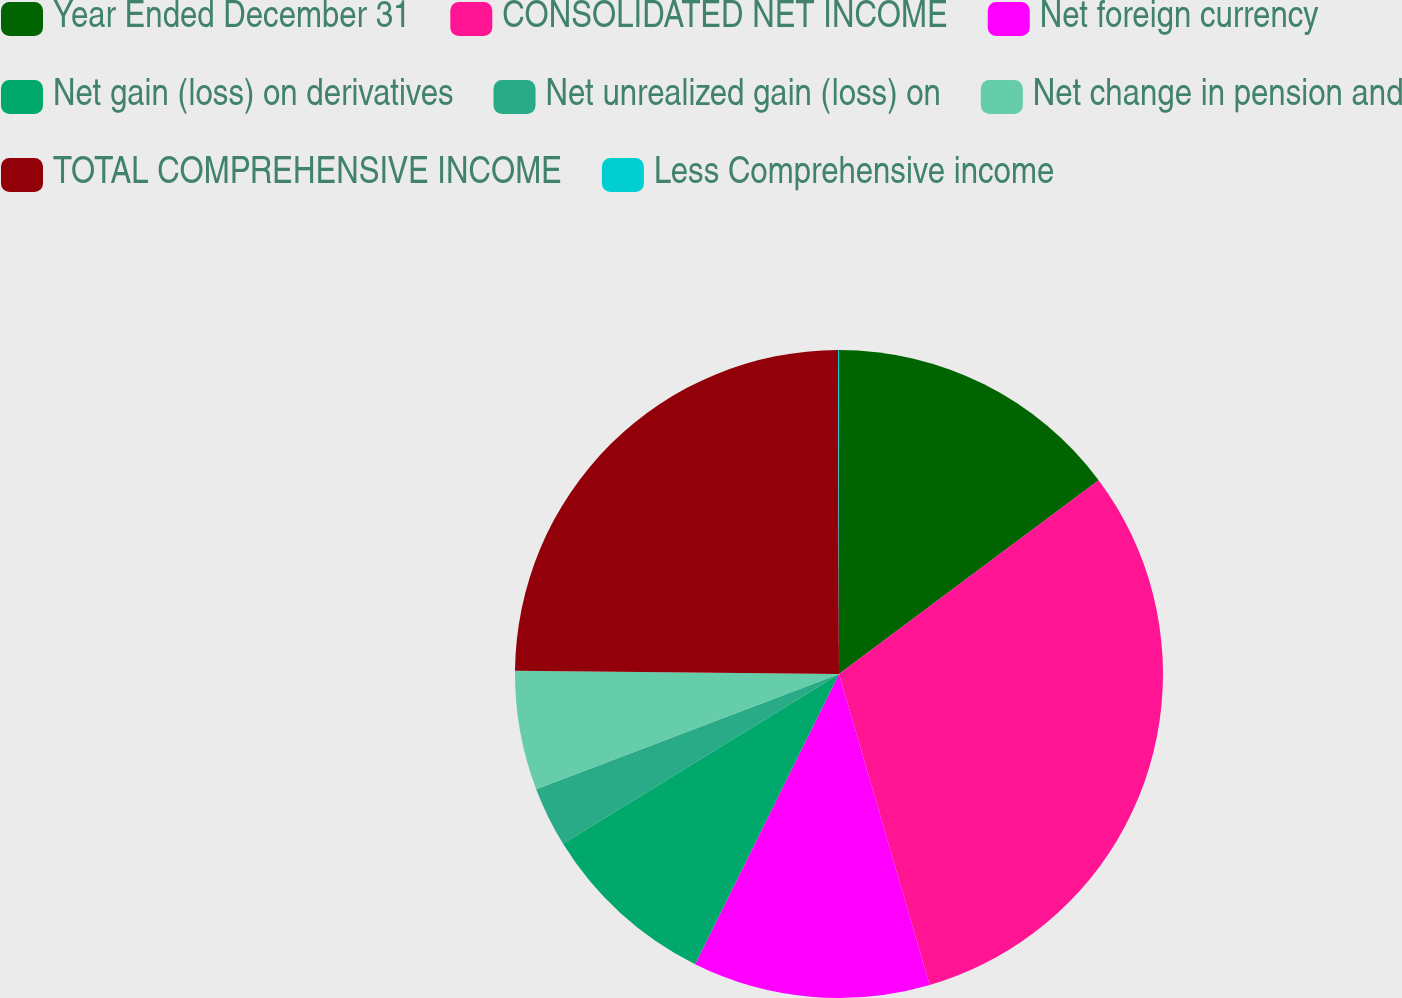<chart> <loc_0><loc_0><loc_500><loc_500><pie_chart><fcel>Year Ended December 31<fcel>CONSOLIDATED NET INCOME<fcel>Net foreign currency<fcel>Net gain (loss) on derivatives<fcel>Net unrealized gain (loss) on<fcel>Net change in pension and<fcel>TOTAL COMPREHENSIVE INCOME<fcel>Less Comprehensive income<nl><fcel>14.79%<fcel>30.69%<fcel>11.84%<fcel>8.89%<fcel>3.0%<fcel>5.94%<fcel>24.79%<fcel>0.05%<nl></chart> 